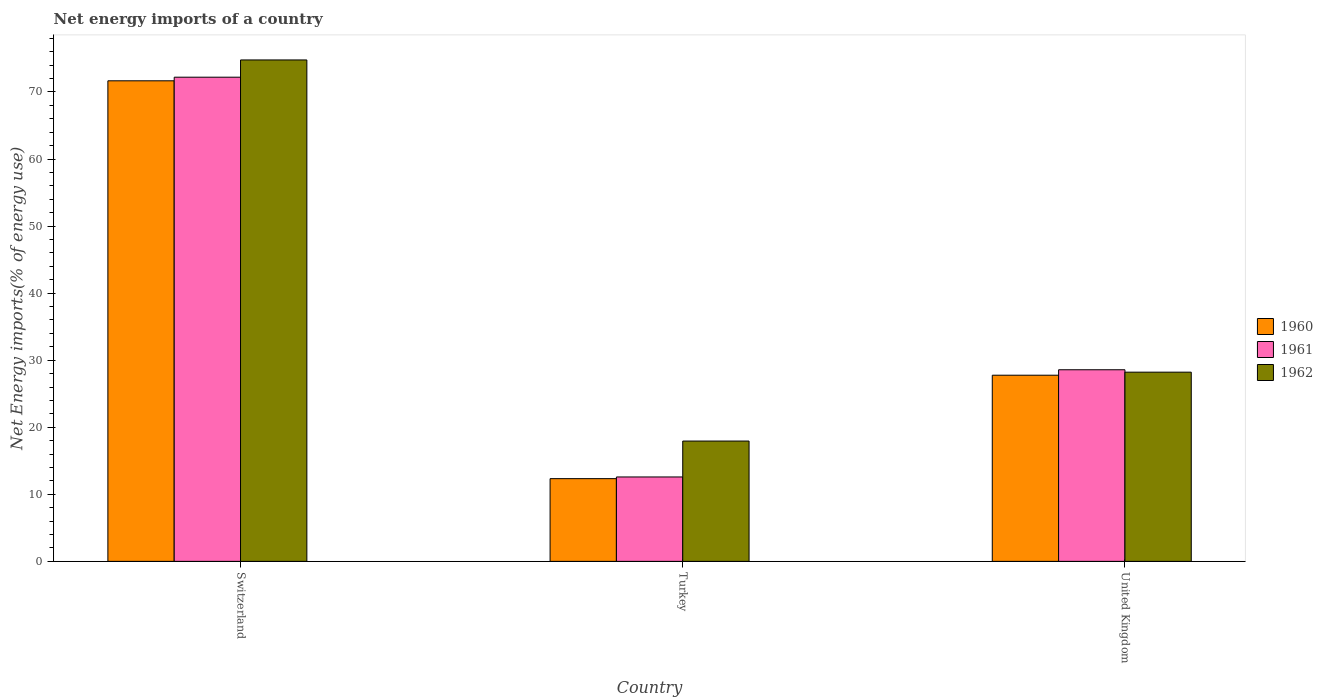How many different coloured bars are there?
Your response must be concise. 3. How many groups of bars are there?
Your answer should be very brief. 3. What is the label of the 3rd group of bars from the left?
Make the answer very short. United Kingdom. In how many cases, is the number of bars for a given country not equal to the number of legend labels?
Offer a very short reply. 0. What is the net energy imports in 1961 in Switzerland?
Provide a short and direct response. 72.21. Across all countries, what is the maximum net energy imports in 1962?
Give a very brief answer. 74.78. Across all countries, what is the minimum net energy imports in 1962?
Offer a very short reply. 17.94. In which country was the net energy imports in 1961 maximum?
Provide a short and direct response. Switzerland. What is the total net energy imports in 1962 in the graph?
Your answer should be very brief. 120.94. What is the difference between the net energy imports in 1962 in Switzerland and that in United Kingdom?
Your answer should be very brief. 46.56. What is the difference between the net energy imports in 1961 in Switzerland and the net energy imports in 1962 in Turkey?
Make the answer very short. 54.26. What is the average net energy imports in 1960 per country?
Make the answer very short. 37.26. What is the difference between the net energy imports of/in 1961 and net energy imports of/in 1962 in Switzerland?
Make the answer very short. -2.57. In how many countries, is the net energy imports in 1960 greater than 68 %?
Your answer should be very brief. 1. What is the ratio of the net energy imports in 1962 in Turkey to that in United Kingdom?
Your answer should be very brief. 0.64. Is the difference between the net energy imports in 1961 in Turkey and United Kingdom greater than the difference between the net energy imports in 1962 in Turkey and United Kingdom?
Your answer should be very brief. No. What is the difference between the highest and the second highest net energy imports in 1961?
Offer a very short reply. 43.63. What is the difference between the highest and the lowest net energy imports in 1961?
Ensure brevity in your answer.  59.62. In how many countries, is the net energy imports in 1960 greater than the average net energy imports in 1960 taken over all countries?
Your answer should be very brief. 1. Is the sum of the net energy imports in 1961 in Switzerland and United Kingdom greater than the maximum net energy imports in 1960 across all countries?
Offer a very short reply. Yes. What does the 3rd bar from the right in Turkey represents?
Ensure brevity in your answer.  1960. Is it the case that in every country, the sum of the net energy imports in 1961 and net energy imports in 1960 is greater than the net energy imports in 1962?
Your answer should be compact. Yes. Are all the bars in the graph horizontal?
Your answer should be very brief. No. What is the difference between two consecutive major ticks on the Y-axis?
Your answer should be compact. 10. Are the values on the major ticks of Y-axis written in scientific E-notation?
Ensure brevity in your answer.  No. Does the graph contain grids?
Your response must be concise. No. How many legend labels are there?
Make the answer very short. 3. What is the title of the graph?
Offer a terse response. Net energy imports of a country. Does "2015" appear as one of the legend labels in the graph?
Ensure brevity in your answer.  No. What is the label or title of the X-axis?
Your response must be concise. Country. What is the label or title of the Y-axis?
Your answer should be very brief. Net Energy imports(% of energy use). What is the Net Energy imports(% of energy use) in 1960 in Switzerland?
Your response must be concise. 71.67. What is the Net Energy imports(% of energy use) in 1961 in Switzerland?
Make the answer very short. 72.21. What is the Net Energy imports(% of energy use) of 1962 in Switzerland?
Provide a succinct answer. 74.78. What is the Net Energy imports(% of energy use) of 1960 in Turkey?
Give a very brief answer. 12.34. What is the Net Energy imports(% of energy use) of 1961 in Turkey?
Offer a terse response. 12.59. What is the Net Energy imports(% of energy use) in 1962 in Turkey?
Offer a very short reply. 17.94. What is the Net Energy imports(% of energy use) of 1960 in United Kingdom?
Offer a terse response. 27.76. What is the Net Energy imports(% of energy use) of 1961 in United Kingdom?
Your answer should be very brief. 28.58. What is the Net Energy imports(% of energy use) of 1962 in United Kingdom?
Your answer should be very brief. 28.22. Across all countries, what is the maximum Net Energy imports(% of energy use) in 1960?
Your answer should be compact. 71.67. Across all countries, what is the maximum Net Energy imports(% of energy use) in 1961?
Keep it short and to the point. 72.21. Across all countries, what is the maximum Net Energy imports(% of energy use) in 1962?
Make the answer very short. 74.78. Across all countries, what is the minimum Net Energy imports(% of energy use) in 1960?
Ensure brevity in your answer.  12.34. Across all countries, what is the minimum Net Energy imports(% of energy use) in 1961?
Offer a terse response. 12.59. Across all countries, what is the minimum Net Energy imports(% of energy use) in 1962?
Your answer should be compact. 17.94. What is the total Net Energy imports(% of energy use) in 1960 in the graph?
Provide a succinct answer. 111.77. What is the total Net Energy imports(% of energy use) in 1961 in the graph?
Provide a succinct answer. 113.37. What is the total Net Energy imports(% of energy use) of 1962 in the graph?
Provide a short and direct response. 120.94. What is the difference between the Net Energy imports(% of energy use) of 1960 in Switzerland and that in Turkey?
Provide a short and direct response. 59.33. What is the difference between the Net Energy imports(% of energy use) in 1961 in Switzerland and that in Turkey?
Provide a succinct answer. 59.62. What is the difference between the Net Energy imports(% of energy use) in 1962 in Switzerland and that in Turkey?
Your answer should be compact. 56.84. What is the difference between the Net Energy imports(% of energy use) of 1960 in Switzerland and that in United Kingdom?
Your answer should be compact. 43.91. What is the difference between the Net Energy imports(% of energy use) in 1961 in Switzerland and that in United Kingdom?
Give a very brief answer. 43.63. What is the difference between the Net Energy imports(% of energy use) in 1962 in Switzerland and that in United Kingdom?
Provide a short and direct response. 46.56. What is the difference between the Net Energy imports(% of energy use) of 1960 in Turkey and that in United Kingdom?
Make the answer very short. -15.43. What is the difference between the Net Energy imports(% of energy use) in 1961 in Turkey and that in United Kingdom?
Give a very brief answer. -15.99. What is the difference between the Net Energy imports(% of energy use) of 1962 in Turkey and that in United Kingdom?
Keep it short and to the point. -10.27. What is the difference between the Net Energy imports(% of energy use) in 1960 in Switzerland and the Net Energy imports(% of energy use) in 1961 in Turkey?
Provide a short and direct response. 59.08. What is the difference between the Net Energy imports(% of energy use) of 1960 in Switzerland and the Net Energy imports(% of energy use) of 1962 in Turkey?
Your answer should be very brief. 53.73. What is the difference between the Net Energy imports(% of energy use) of 1961 in Switzerland and the Net Energy imports(% of energy use) of 1962 in Turkey?
Ensure brevity in your answer.  54.26. What is the difference between the Net Energy imports(% of energy use) in 1960 in Switzerland and the Net Energy imports(% of energy use) in 1961 in United Kingdom?
Provide a succinct answer. 43.09. What is the difference between the Net Energy imports(% of energy use) of 1960 in Switzerland and the Net Energy imports(% of energy use) of 1962 in United Kingdom?
Your answer should be very brief. 43.45. What is the difference between the Net Energy imports(% of energy use) in 1961 in Switzerland and the Net Energy imports(% of energy use) in 1962 in United Kingdom?
Offer a terse response. 43.99. What is the difference between the Net Energy imports(% of energy use) of 1960 in Turkey and the Net Energy imports(% of energy use) of 1961 in United Kingdom?
Keep it short and to the point. -16.24. What is the difference between the Net Energy imports(% of energy use) of 1960 in Turkey and the Net Energy imports(% of energy use) of 1962 in United Kingdom?
Provide a short and direct response. -15.88. What is the difference between the Net Energy imports(% of energy use) in 1961 in Turkey and the Net Energy imports(% of energy use) in 1962 in United Kingdom?
Provide a short and direct response. -15.63. What is the average Net Energy imports(% of energy use) of 1960 per country?
Ensure brevity in your answer.  37.26. What is the average Net Energy imports(% of energy use) in 1961 per country?
Your answer should be very brief. 37.79. What is the average Net Energy imports(% of energy use) of 1962 per country?
Provide a short and direct response. 40.31. What is the difference between the Net Energy imports(% of energy use) in 1960 and Net Energy imports(% of energy use) in 1961 in Switzerland?
Make the answer very short. -0.54. What is the difference between the Net Energy imports(% of energy use) of 1960 and Net Energy imports(% of energy use) of 1962 in Switzerland?
Keep it short and to the point. -3.11. What is the difference between the Net Energy imports(% of energy use) in 1961 and Net Energy imports(% of energy use) in 1962 in Switzerland?
Your answer should be very brief. -2.57. What is the difference between the Net Energy imports(% of energy use) of 1960 and Net Energy imports(% of energy use) of 1961 in Turkey?
Offer a very short reply. -0.25. What is the difference between the Net Energy imports(% of energy use) in 1960 and Net Energy imports(% of energy use) in 1962 in Turkey?
Offer a terse response. -5.61. What is the difference between the Net Energy imports(% of energy use) in 1961 and Net Energy imports(% of energy use) in 1962 in Turkey?
Provide a succinct answer. -5.36. What is the difference between the Net Energy imports(% of energy use) of 1960 and Net Energy imports(% of energy use) of 1961 in United Kingdom?
Your response must be concise. -0.81. What is the difference between the Net Energy imports(% of energy use) in 1960 and Net Energy imports(% of energy use) in 1962 in United Kingdom?
Offer a very short reply. -0.45. What is the difference between the Net Energy imports(% of energy use) in 1961 and Net Energy imports(% of energy use) in 1962 in United Kingdom?
Your answer should be very brief. 0.36. What is the ratio of the Net Energy imports(% of energy use) of 1960 in Switzerland to that in Turkey?
Give a very brief answer. 5.81. What is the ratio of the Net Energy imports(% of energy use) of 1961 in Switzerland to that in Turkey?
Your answer should be very brief. 5.74. What is the ratio of the Net Energy imports(% of energy use) in 1962 in Switzerland to that in Turkey?
Ensure brevity in your answer.  4.17. What is the ratio of the Net Energy imports(% of energy use) of 1960 in Switzerland to that in United Kingdom?
Offer a very short reply. 2.58. What is the ratio of the Net Energy imports(% of energy use) in 1961 in Switzerland to that in United Kingdom?
Provide a succinct answer. 2.53. What is the ratio of the Net Energy imports(% of energy use) of 1962 in Switzerland to that in United Kingdom?
Offer a terse response. 2.65. What is the ratio of the Net Energy imports(% of energy use) of 1960 in Turkey to that in United Kingdom?
Provide a short and direct response. 0.44. What is the ratio of the Net Energy imports(% of energy use) in 1961 in Turkey to that in United Kingdom?
Ensure brevity in your answer.  0.44. What is the ratio of the Net Energy imports(% of energy use) of 1962 in Turkey to that in United Kingdom?
Provide a succinct answer. 0.64. What is the difference between the highest and the second highest Net Energy imports(% of energy use) in 1960?
Give a very brief answer. 43.91. What is the difference between the highest and the second highest Net Energy imports(% of energy use) of 1961?
Your answer should be compact. 43.63. What is the difference between the highest and the second highest Net Energy imports(% of energy use) of 1962?
Your answer should be very brief. 46.56. What is the difference between the highest and the lowest Net Energy imports(% of energy use) of 1960?
Keep it short and to the point. 59.33. What is the difference between the highest and the lowest Net Energy imports(% of energy use) in 1961?
Your answer should be compact. 59.62. What is the difference between the highest and the lowest Net Energy imports(% of energy use) in 1962?
Your response must be concise. 56.84. 